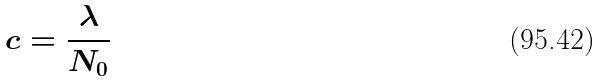Convert formula to latex. <formula><loc_0><loc_0><loc_500><loc_500>c = \frac { \lambda } { N _ { 0 } }</formula> 